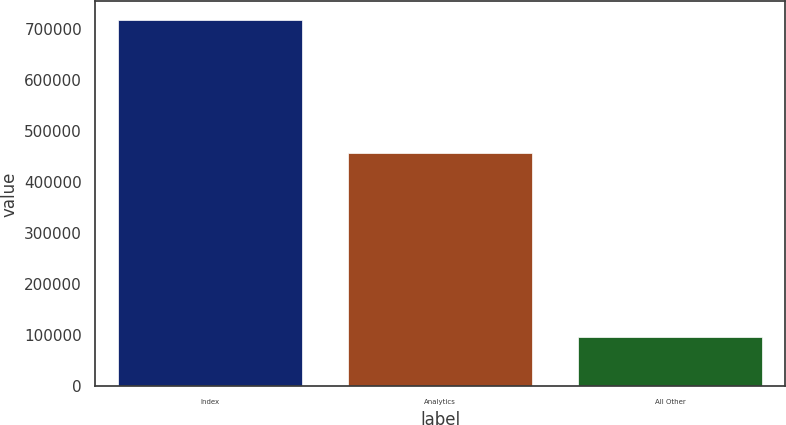<chart> <loc_0><loc_0><loc_500><loc_500><bar_chart><fcel>Index<fcel>Analytics<fcel>All Other<nl><fcel>718959<fcel>458269<fcel>96944<nl></chart> 